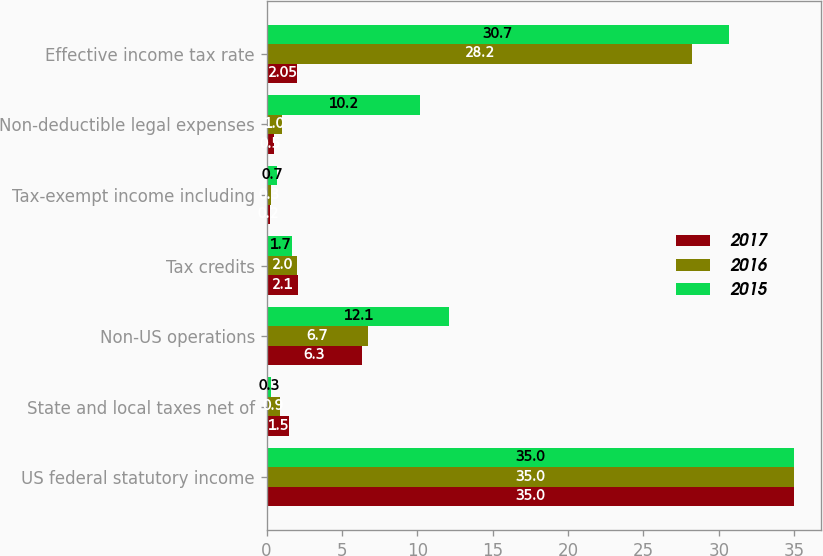Convert chart to OTSL. <chart><loc_0><loc_0><loc_500><loc_500><stacked_bar_chart><ecel><fcel>US federal statutory income<fcel>State and local taxes net of<fcel>Non-US operations<fcel>Tax credits<fcel>Tax-exempt income including<fcel>Non-deductible legal expenses<fcel>Effective income tax rate<nl><fcel>2017<fcel>35<fcel>1.5<fcel>6.3<fcel>2.1<fcel>0.2<fcel>0.5<fcel>2.05<nl><fcel>2016<fcel>35<fcel>0.9<fcel>6.7<fcel>2<fcel>0.3<fcel>1<fcel>28.2<nl><fcel>2015<fcel>35<fcel>0.3<fcel>12.1<fcel>1.7<fcel>0.7<fcel>10.2<fcel>30.7<nl></chart> 